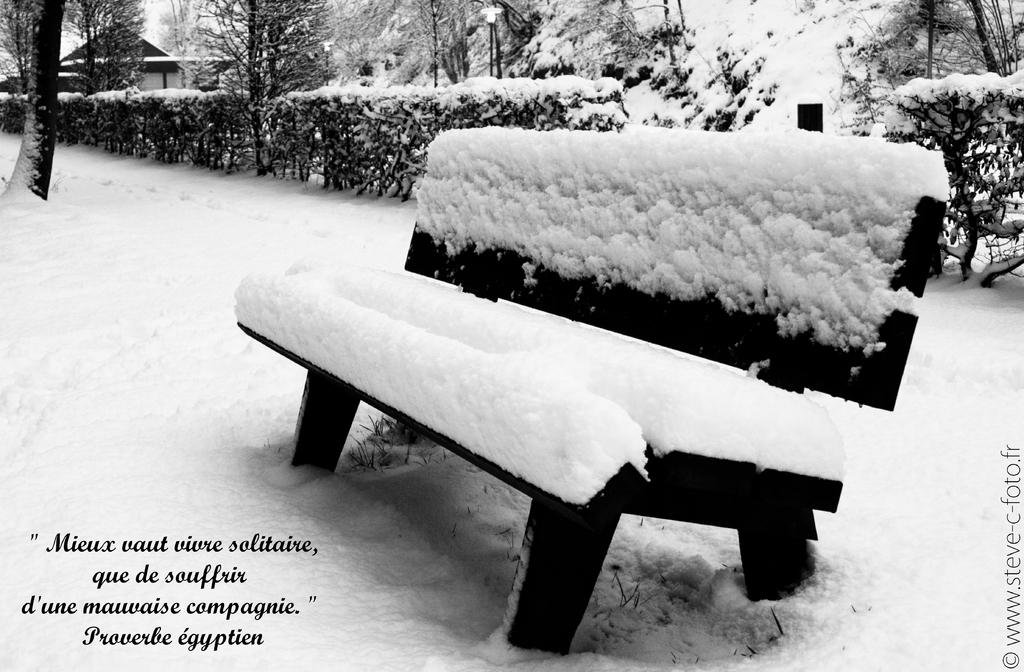What type of outdoor furniture is in the image? There is a bench in the image. What type of vegetation is present in the image? There are trees, bushes, and sheds in the image. What structures can be seen in the image? There are sheds and poles in the image. What type of illumination is present in the image? A light is present in the image. How is the entire scene in the image affected? All of these elements are covered by snow. What is visible at the bottom of the image? There is some text and snow at the bottom of the image. What type of drug is being sold in the image? There is no indication of any drug being sold or present in the image. What type of crayon is being used to write the text at the bottom of the image? There is no crayon visible in the image, and the text appears to be printed or written with a different medium. 